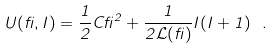<formula> <loc_0><loc_0><loc_500><loc_500>U ( \beta , I ) = \frac { 1 } { 2 } C { \beta } ^ { 2 } + \frac { 1 } { 2 { \mathcal { L } } ( \beta ) } I ( I + 1 ) \ .</formula> 